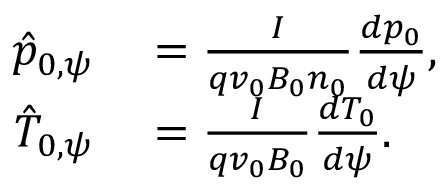Convert formula to latex. <formula><loc_0><loc_0><loc_500><loc_500>\begin{array} { r l } { \hat { p } _ { 0 , \psi } } & = \frac { I } { q v _ { 0 } B _ { 0 } n _ { 0 } } \frac { d p _ { 0 } } { d \psi } , } \\ { \hat { T } _ { 0 , \psi } } & = \frac { I } { q v _ { 0 } B _ { 0 } } \frac { d T _ { 0 } } { d \psi } . } \end{array}</formula> 